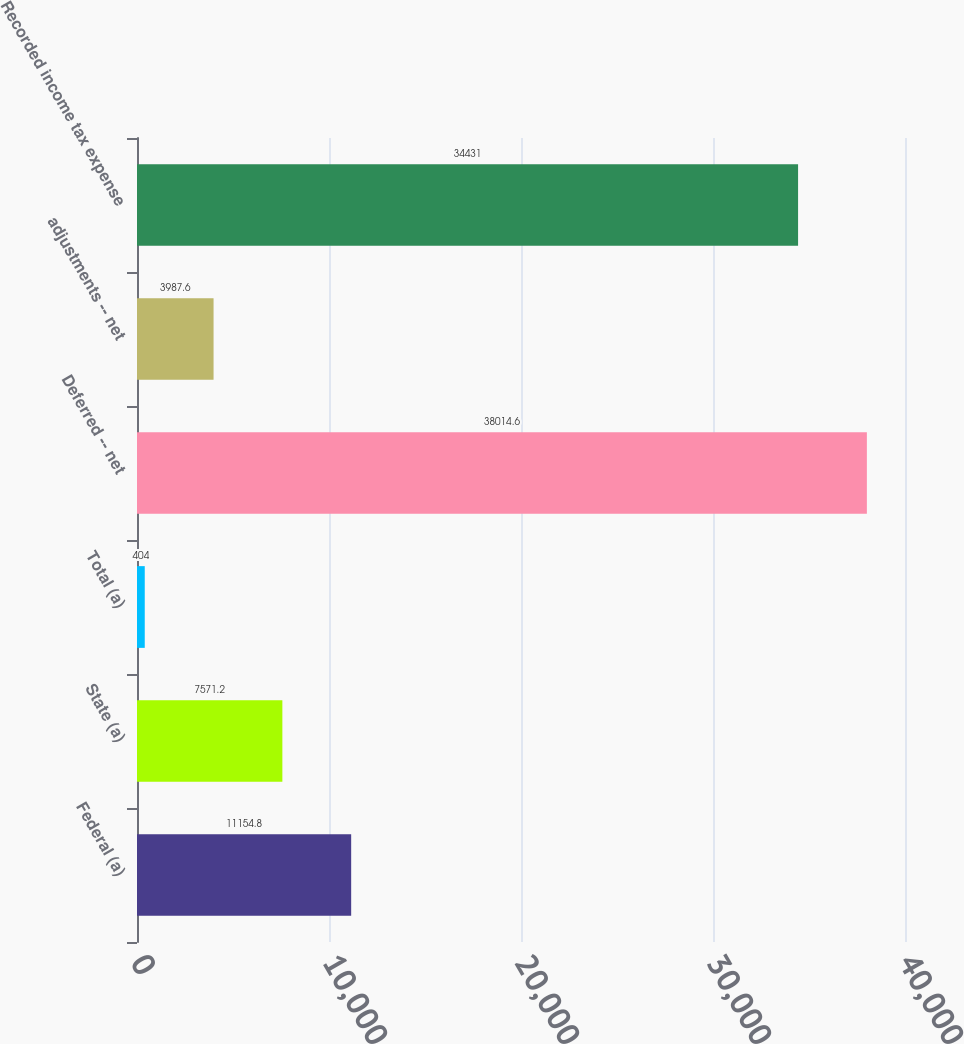<chart> <loc_0><loc_0><loc_500><loc_500><bar_chart><fcel>Federal (a)<fcel>State (a)<fcel>Total (a)<fcel>Deferred -- net<fcel>adjustments -- net<fcel>Recorded income tax expense<nl><fcel>11154.8<fcel>7571.2<fcel>404<fcel>38014.6<fcel>3987.6<fcel>34431<nl></chart> 